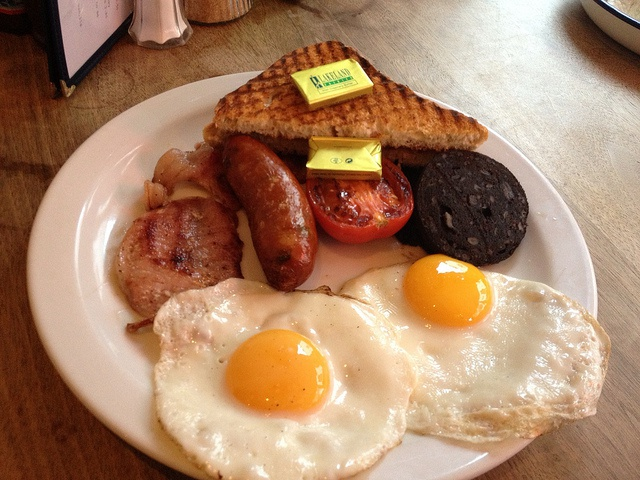Describe the objects in this image and their specific colors. I can see dining table in maroon, tan, ivory, and brown tones, sandwich in black, brown, and maroon tones, and hot dog in black, maroon, and brown tones in this image. 